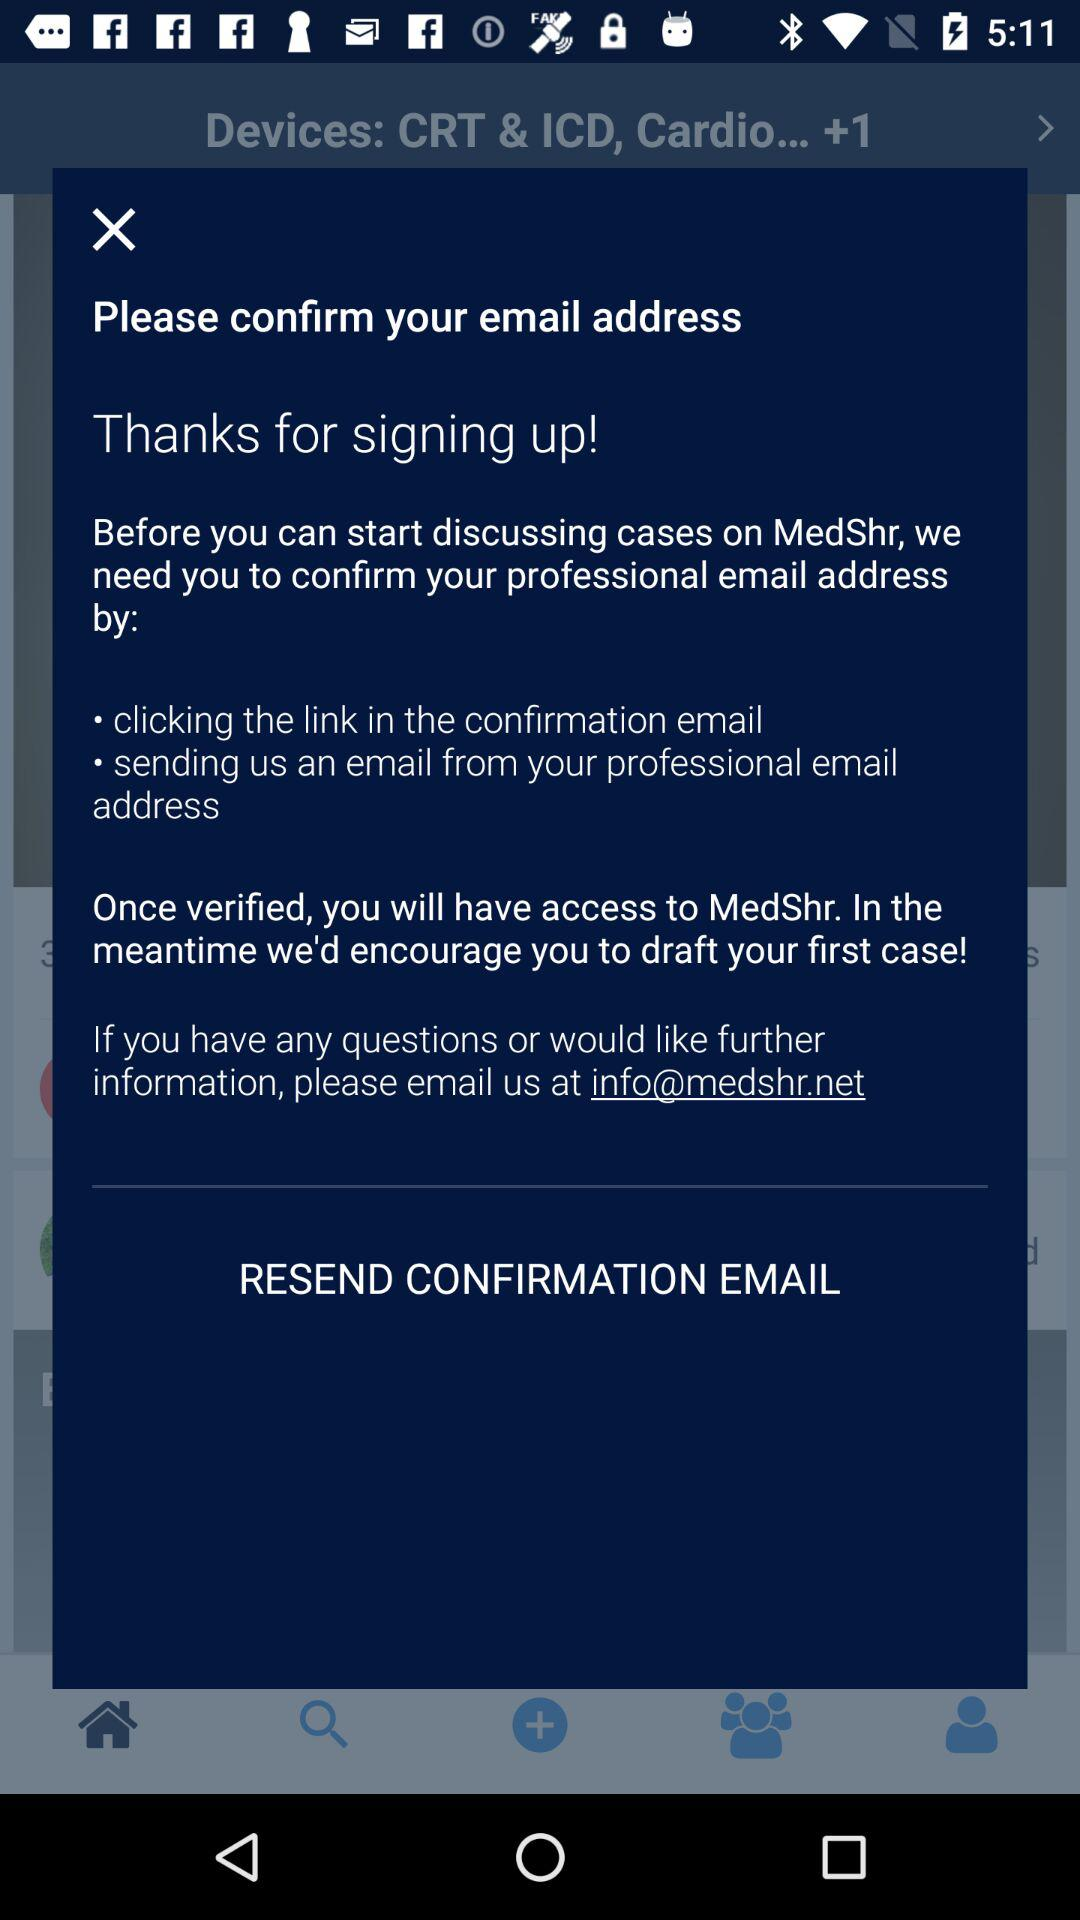How many steps are there to confirm your email address?
Answer the question using a single word or phrase. 2 